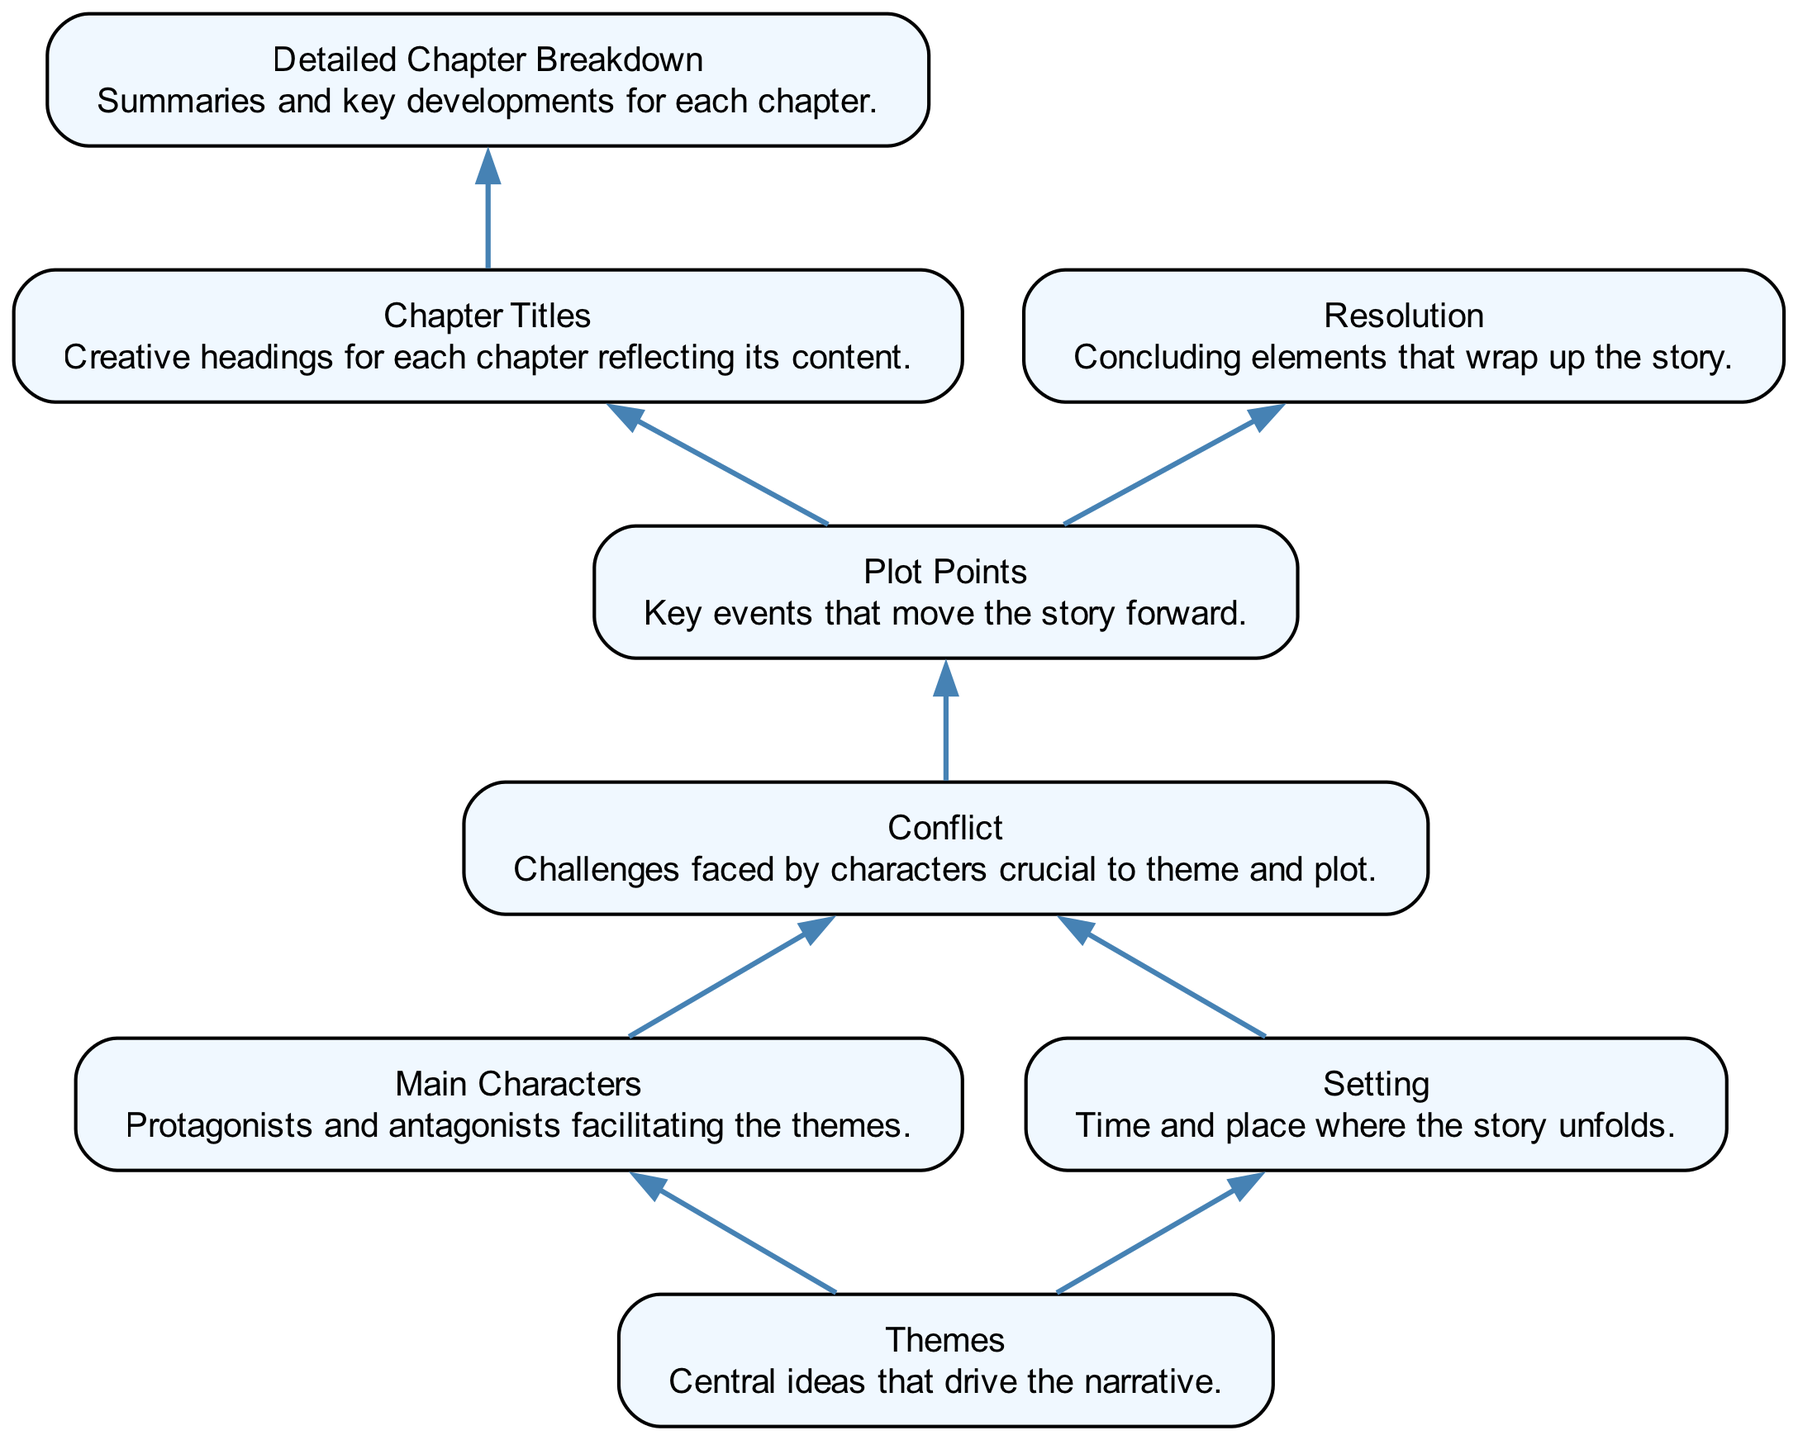What is the top node in the diagram? The top node is "Themes," which is the starting point of the outlining process. It represents the central ideas that drive the narrative.
Answer: Themes How many main nodes are there? The diagram features eight main nodes, including "Themes," "Main Characters," "Setting," "Plot Points," "Chapter Titles," "Detailed Chapter Breakdown," "Conflict," and "Resolution." Each of these nodes represents a key component of the story outlining process.
Answer: 8 What node comes directly after "Conflict"? The node that comes directly after "Conflict" is "Plot Points." This indicates that after establishing a conflict, the outlining process moves to identify key events that propel the story forward.
Answer: Plot Points Which two nodes are connected to "Conflict"? The two nodes connected to "Conflict" are "Main Characters" and "Setting." This shows that both characters and the setting contribute to the story's conflict.
Answer: Main Characters, Setting What is the relationship between "Plot Points" and "Resolution"? "Plot Points" leads to "Resolution." This means that the key events identified in the previous step culminate in the concluding elements of the story that wrap up the narrative.
Answer: Leads to Which node is connected to "Chapter Titles"? The node connected to "Chapter Titles" is "Detailed Chapter Breakdown." This implies that once chapter titles are created, detailed summaries and key developments for each chapter follow.
Answer: Detailed Chapter Breakdown How many edges are there in the diagram? The diagram contains seven edges. Each edge denotes a connection or relationship between two nodes, illustrating the flow of the outlining process.
Answer: 7 What node represents challenges faced by characters? The node representing challenges faced by characters is "Conflict." It plays a crucial role in both the theme and the plot, driving character development and story progression.
Answer: Conflict Which node is the last in the bottom-up flow? The last node in the bottom-up flow is "Resolution." This indicates that the outlining process concludes with the elements that wrap up the story, providing closure to the narrative.
Answer: Resolution 